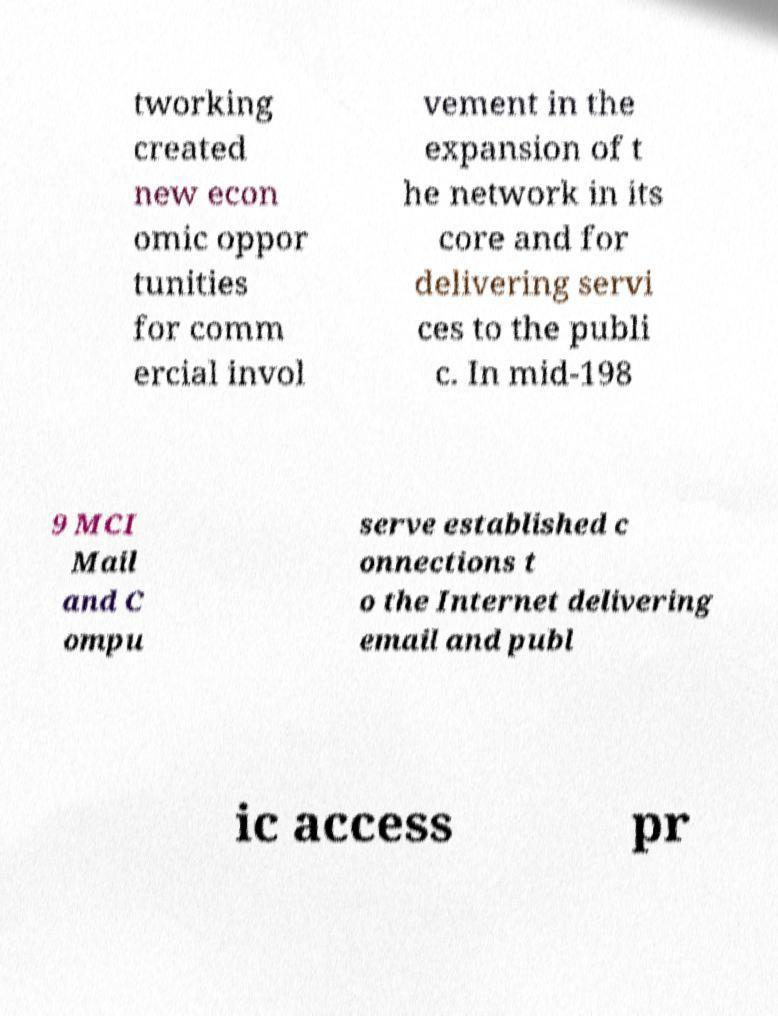Could you assist in decoding the text presented in this image and type it out clearly? tworking created new econ omic oppor tunities for comm ercial invol vement in the expansion of t he network in its core and for delivering servi ces to the publi c. In mid-198 9 MCI Mail and C ompu serve established c onnections t o the Internet delivering email and publ ic access pr 